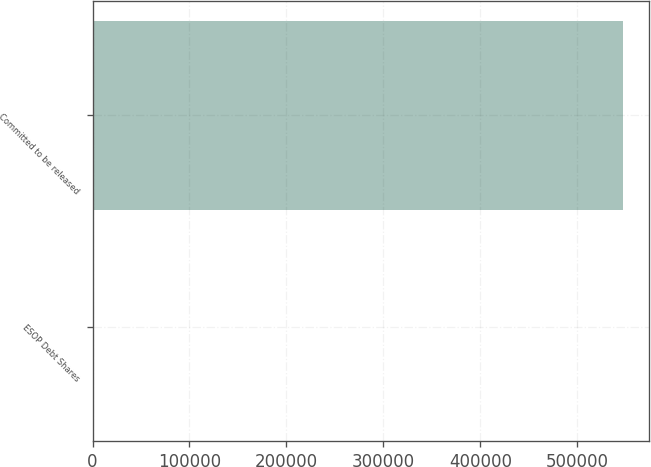Convert chart to OTSL. <chart><loc_0><loc_0><loc_500><loc_500><bar_chart><fcel>ESOP Debt Shares<fcel>Committed to be released<nl><fcel>2003<fcel>546798<nl></chart> 